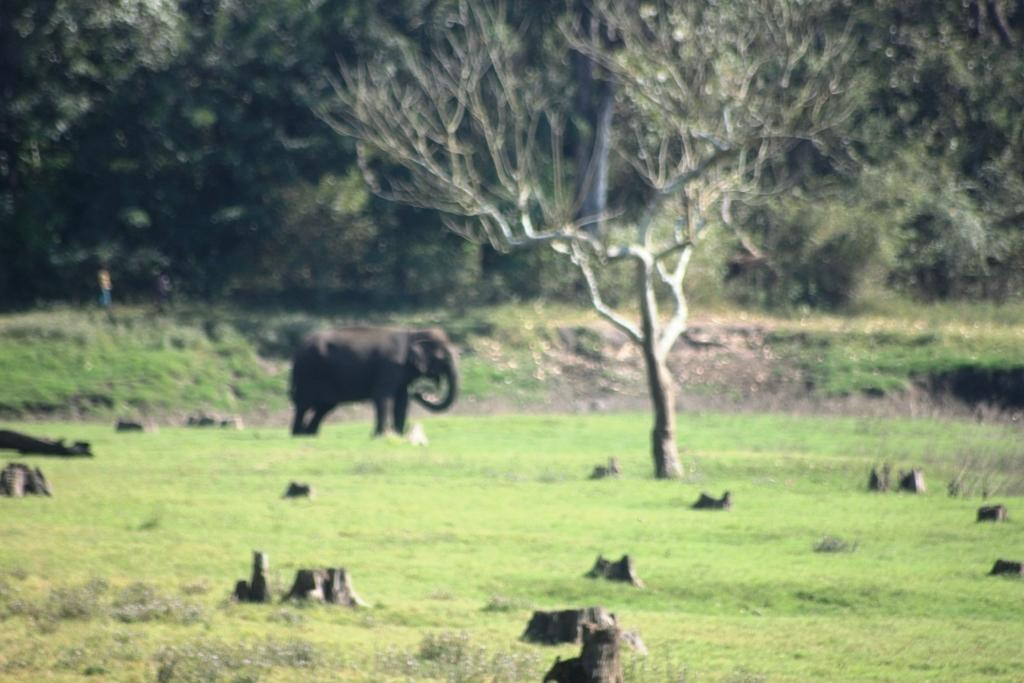What type of terrain is visible in the image? There is a grassy land in the image. What large animal can be seen in the background of the image? There is an elephant in the background of the image. What type of vegetation is visible in the background of the image? There are trees in the background of the image. What type of medical equipment can be seen in the image? There is no medical equipment present in the image. What type of sports equipment can be seen in the image? There is no sports equipment, such as sticks or a net, present in the image. 